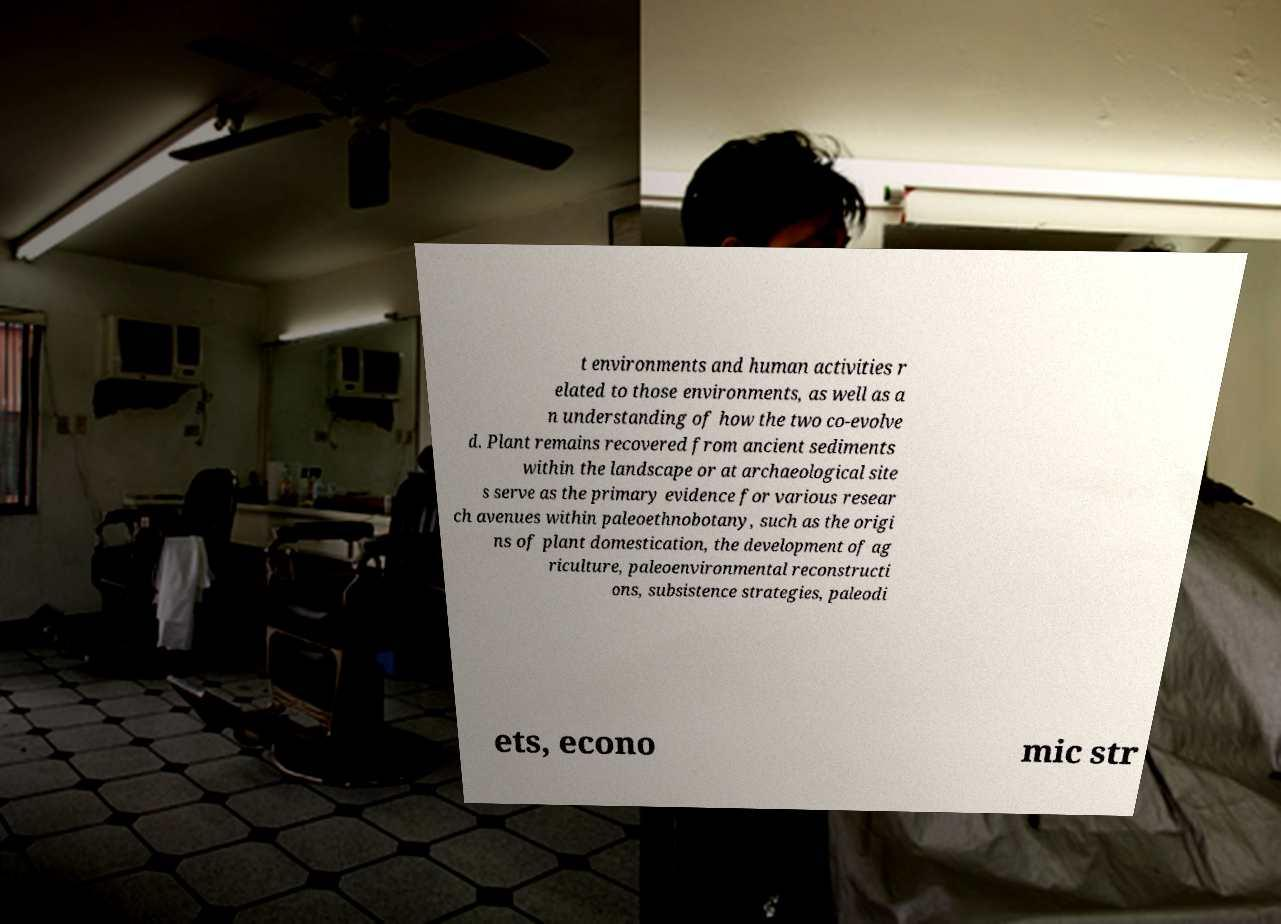For documentation purposes, I need the text within this image transcribed. Could you provide that? t environments and human activities r elated to those environments, as well as a n understanding of how the two co-evolve d. Plant remains recovered from ancient sediments within the landscape or at archaeological site s serve as the primary evidence for various resear ch avenues within paleoethnobotany, such as the origi ns of plant domestication, the development of ag riculture, paleoenvironmental reconstructi ons, subsistence strategies, paleodi ets, econo mic str 